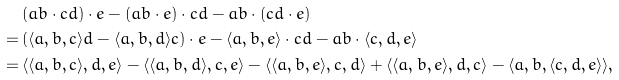<formula> <loc_0><loc_0><loc_500><loc_500>& ( a b \cdot c d ) \cdot e - ( a b \cdot e ) \cdot c d - a b \cdot ( c d \cdot e ) \\ = \, & ( \langle a , b , c \rangle d - \langle a , b , d \rangle c ) \cdot e - \langle a , b , e \rangle \cdot c d - a b \cdot \langle c , d , e \rangle \\ = \, & \langle \langle a , b , c \rangle , d , e \rangle - \langle \langle a , b , d \rangle , c , e \rangle - \langle \langle a , b , e \rangle , c , d \rangle + \langle \langle a , b , e \rangle , d , c \rangle - \langle a , b , \langle c , d , e \rangle \rangle ,</formula> 